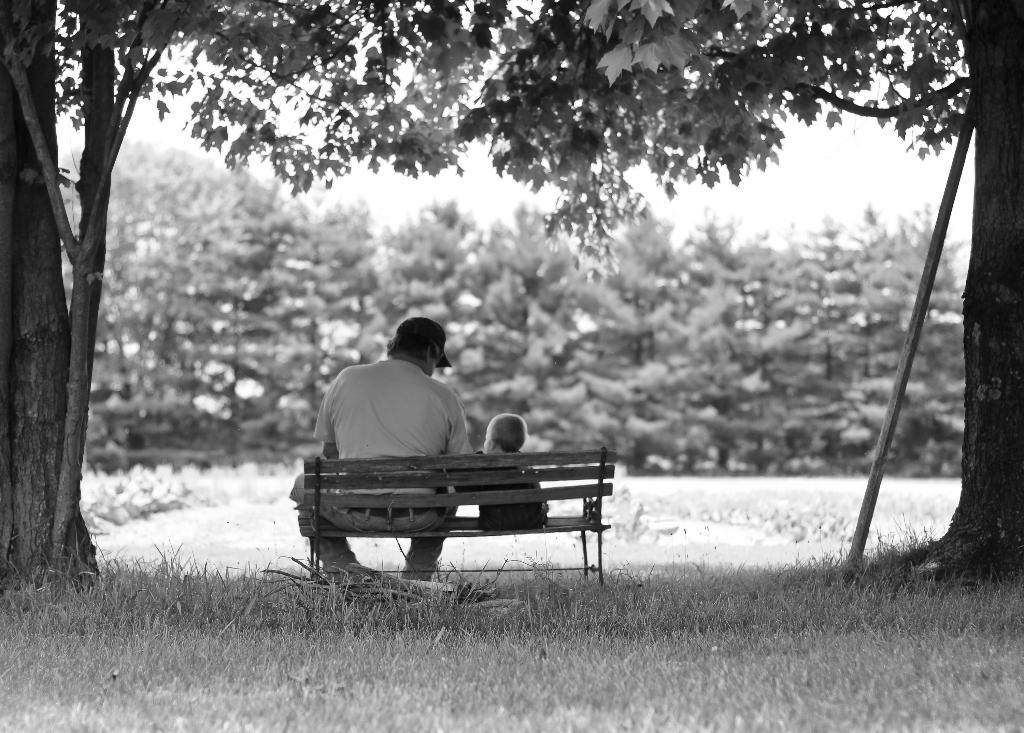What type of outdoor space is shown in the image? There is a garden in the image. What piece of furniture is present in the garden? There is a bench in the garden. Who is sitting on the bench? A person is sitting on the bench. Who is sitting near the bench? A boy is sitting near the bench. What type of vegetation is present in the garden? There are many trees in the garden. What type of ground cover is present in the garden? There is grass on the floor of the garden. What type of business is being conducted in the garden? There is no indication of any business being conducted in the image; it is a garden with a bench and people sitting on it. 